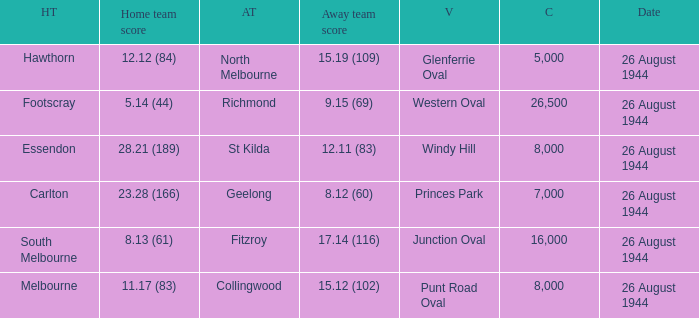Which Venue is the one for the footscray Home team? Western Oval. Could you parse the entire table as a dict? {'header': ['HT', 'Home team score', 'AT', 'Away team score', 'V', 'C', 'Date'], 'rows': [['Hawthorn', '12.12 (84)', 'North Melbourne', '15.19 (109)', 'Glenferrie Oval', '5,000', '26 August 1944'], ['Footscray', '5.14 (44)', 'Richmond', '9.15 (69)', 'Western Oval', '26,500', '26 August 1944'], ['Essendon', '28.21 (189)', 'St Kilda', '12.11 (83)', 'Windy Hill', '8,000', '26 August 1944'], ['Carlton', '23.28 (166)', 'Geelong', '8.12 (60)', 'Princes Park', '7,000', '26 August 1944'], ['South Melbourne', '8.13 (61)', 'Fitzroy', '17.14 (116)', 'Junction Oval', '16,000', '26 August 1944'], ['Melbourne', '11.17 (83)', 'Collingwood', '15.12 (102)', 'Punt Road Oval', '8,000', '26 August 1944']]} 